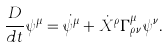<formula> <loc_0><loc_0><loc_500><loc_500>\frac { D } { d t } \psi ^ { \mu } = \dot { \psi } ^ { \mu } + \dot { X } ^ { \rho } \Gamma _ { \rho \nu } ^ { \mu } \psi ^ { \nu } .</formula> 